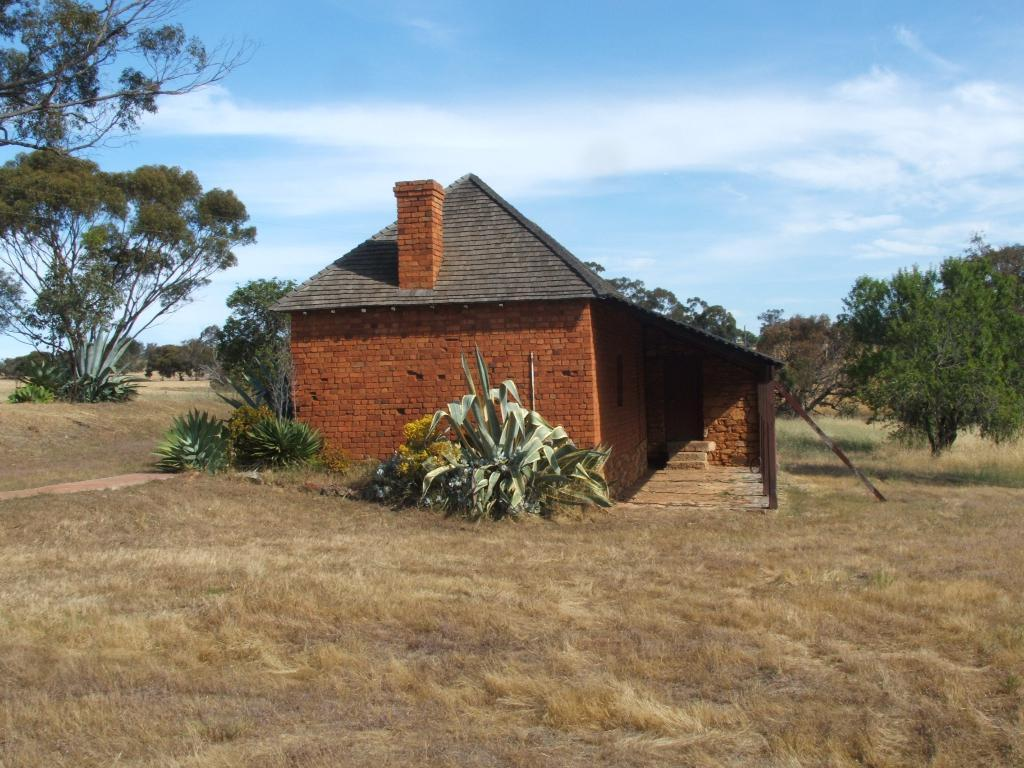What type of structure is visible in the image? There is a house in the image. What objects can be seen near the house? There are rods in the image. What type of vegetation is present in the image? There are trees and plants in the image. What is the ground covered with in the image? The ground is covered with grass. What can be seen in the background of the image? The sky is visible in the background of the image. How many pies are being served on the slip in the image? There is no slip or pies present in the image. 